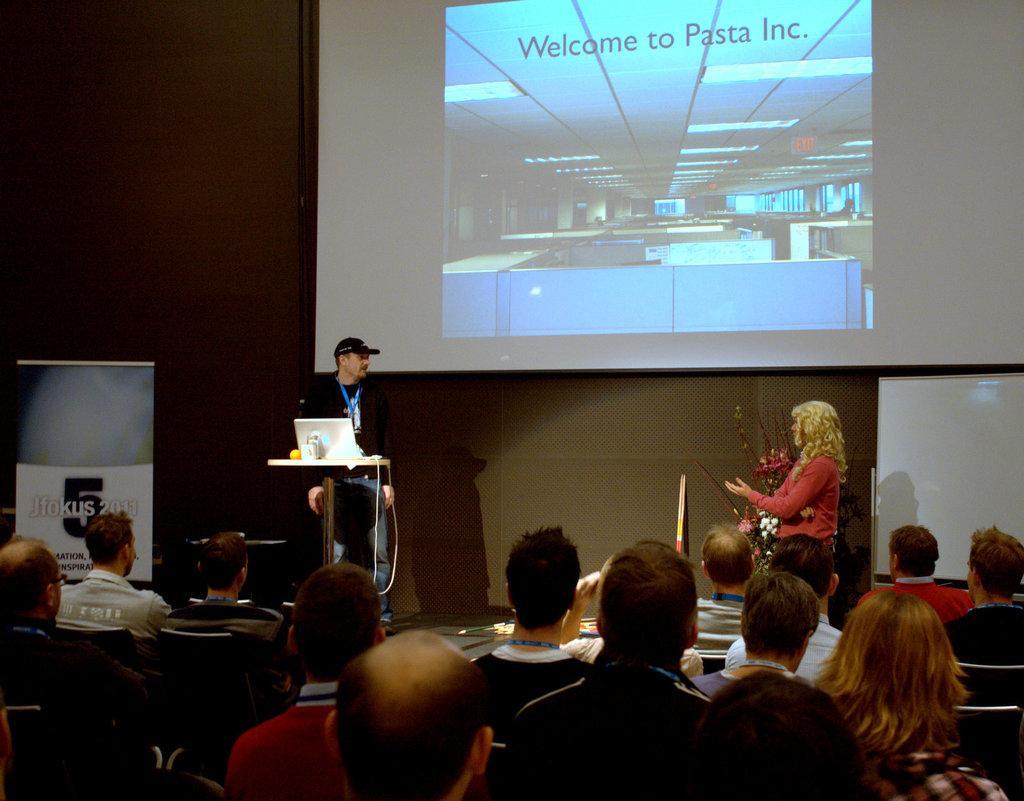Could you give a brief overview of what you see in this image? In this picture, we can see a few people sitting on chairs, and two persons are standing, we can see a table with some objects on it like laptop, and we can see the wall with some objects attached to it like projector screen, board, we can see flower pot, and we can see some poster. 